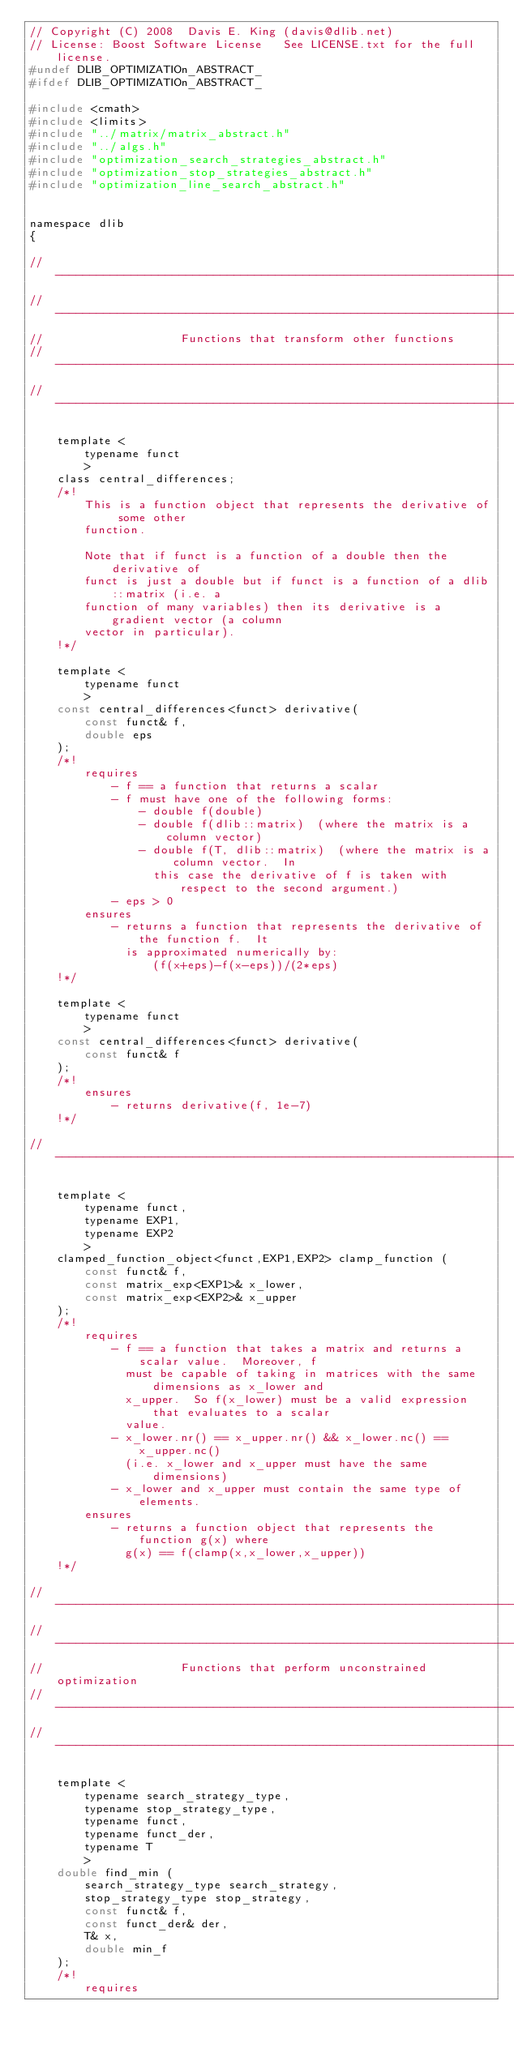Convert code to text. <code><loc_0><loc_0><loc_500><loc_500><_C_>// Copyright (C) 2008  Davis E. King (davis@dlib.net)
// License: Boost Software License   See LICENSE.txt for the full license.
#undef DLIB_OPTIMIZATIOn_ABSTRACT_
#ifdef DLIB_OPTIMIZATIOn_ABSTRACT_

#include <cmath>
#include <limits>
#include "../matrix/matrix_abstract.h"
#include "../algs.h"
#include "optimization_search_strategies_abstract.h"
#include "optimization_stop_strategies_abstract.h"
#include "optimization_line_search_abstract.h"


namespace dlib
{

// ----------------------------------------------------------------------------------------
// ----------------------------------------------------------------------------------------
//                    Functions that transform other functions  
// ----------------------------------------------------------------------------------------
// ----------------------------------------------------------------------------------------

    template <
        typename funct
        >
    class central_differences;
    /*!
        This is a function object that represents the derivative of some other
        function. 

        Note that if funct is a function of a double then the derivative of 
        funct is just a double but if funct is a function of a dlib::matrix (i.e. a
        function of many variables) then its derivative is a gradient vector (a column
        vector in particular).
    !*/

    template <
        typename funct
        >
    const central_differences<funct> derivative(
        const funct& f, 
        double eps
    );
    /*!
        requires
            - f == a function that returns a scalar
            - f must have one of the following forms:
                - double f(double)
                - double f(dlib::matrix)  (where the matrix is a column vector)
                - double f(T, dlib::matrix)  (where the matrix is a column vector.  In 
                  this case the derivative of f is taken with respect to the second argument.)
            - eps > 0
        ensures
            - returns a function that represents the derivative of the function f.  It
              is approximated numerically by:
                  (f(x+eps)-f(x-eps))/(2*eps)
    !*/

    template <
        typename funct
        >
    const central_differences<funct> derivative(
        const funct& f
    );
    /*!
        ensures
            - returns derivative(f, 1e-7)
    !*/

// ----------------------------------------------------------------------------------------

    template <
        typename funct, 
        typename EXP1, 
        typename EXP2
        >
    clamped_function_object<funct,EXP1,EXP2> clamp_function (
        const funct& f,
        const matrix_exp<EXP1>& x_lower,
        const matrix_exp<EXP2>& x_upper 
    );
    /*!
        requires
            - f == a function that takes a matrix and returns a scalar value.  Moreover, f
              must be capable of taking in matrices with the same dimensions as x_lower and
              x_upper.  So f(x_lower) must be a valid expression that evaluates to a scalar
              value.
            - x_lower.nr() == x_upper.nr() && x_lower.nc() == x_upper.nc()
              (i.e. x_lower and x_upper must have the same dimensions)
            - x_lower and x_upper must contain the same type of elements.
        ensures
            - returns a function object that represents the function g(x) where
              g(x) == f(clamp(x,x_lower,x_upper))
    !*/

// ----------------------------------------------------------------------------------------
// ----------------------------------------------------------------------------------------
//                    Functions that perform unconstrained optimization 
// ----------------------------------------------------------------------------------------
// ----------------------------------------------------------------------------------------

    template <
        typename search_strategy_type,
        typename stop_strategy_type,
        typename funct, 
        typename funct_der, 
        typename T
        >
    double find_min (
        search_strategy_type search_strategy,
        stop_strategy_type stop_strategy,
        const funct& f, 
        const funct_der& der, 
        T& x, 
        double min_f
    );
    /*!
        requires</code> 